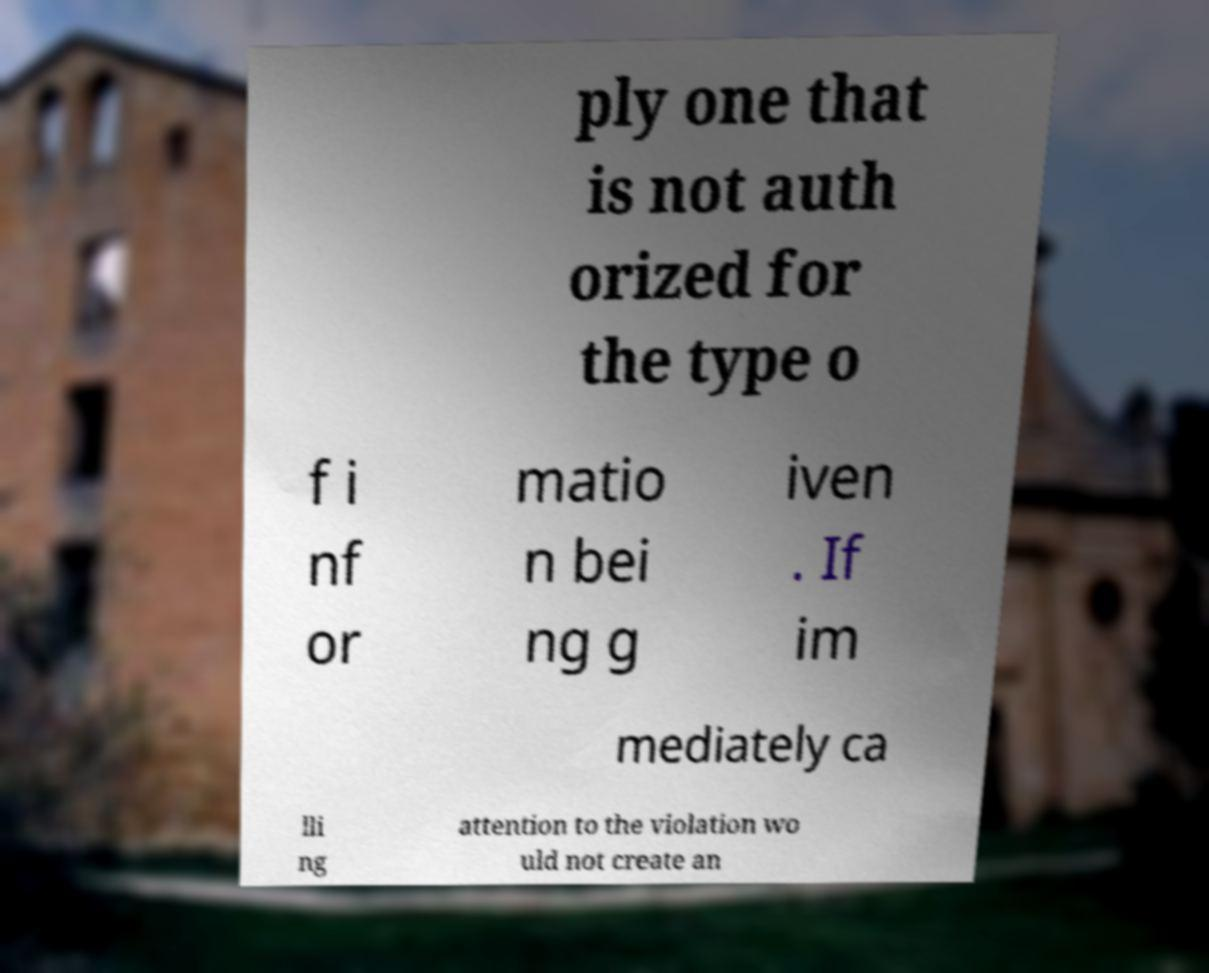There's text embedded in this image that I need extracted. Can you transcribe it verbatim? ply one that is not auth orized for the type o f i nf or matio n bei ng g iven . If im mediately ca lli ng attention to the violation wo uld not create an 